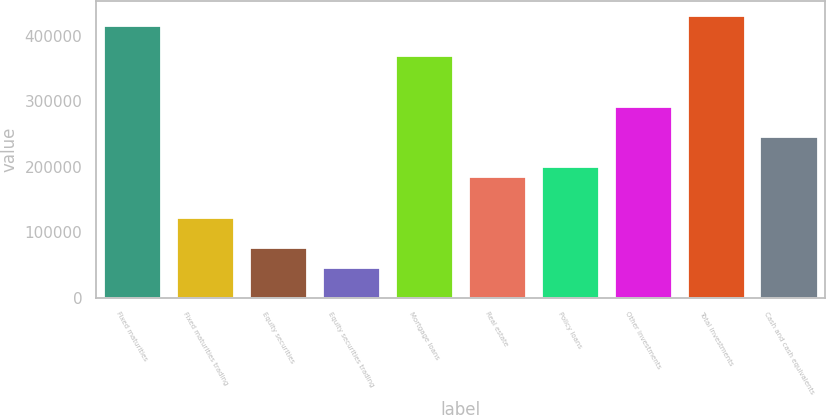Convert chart. <chart><loc_0><loc_0><loc_500><loc_500><bar_chart><fcel>Fixed maturities<fcel>Fixed maturities trading<fcel>Equity securities<fcel>Equity securities trading<fcel>Mortgage loans<fcel>Real estate<fcel>Policy loans<fcel>Other investments<fcel>Total investments<fcel>Cash and cash equivalents<nl><fcel>417204<fcel>123616<fcel>77260.1<fcel>46356.1<fcel>370848<fcel>185424<fcel>200876<fcel>293588<fcel>432656<fcel>247232<nl></chart> 